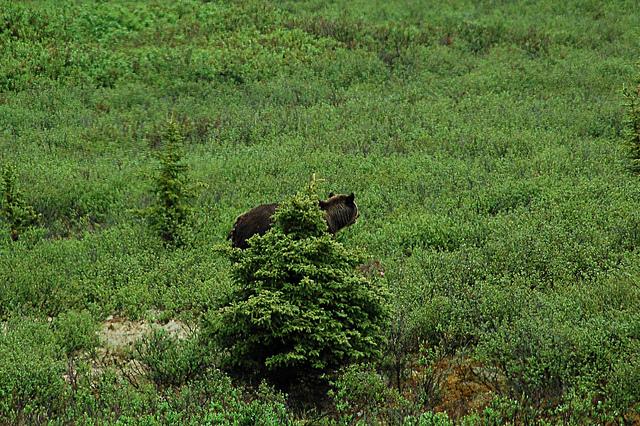Is the bear shown real?
Quick response, please. Yes. How many different colors of leaves are there?
Give a very brief answer. 1. Is the bear black?
Quick response, please. Yes. What kind of animal is in the image?
Write a very short answer. Bear. What is the main color in this picture?
Give a very brief answer. Green. What is blocking a partial view of the animal?
Keep it brief. Bush. Does the bear see the camera?
Answer briefly. No. 